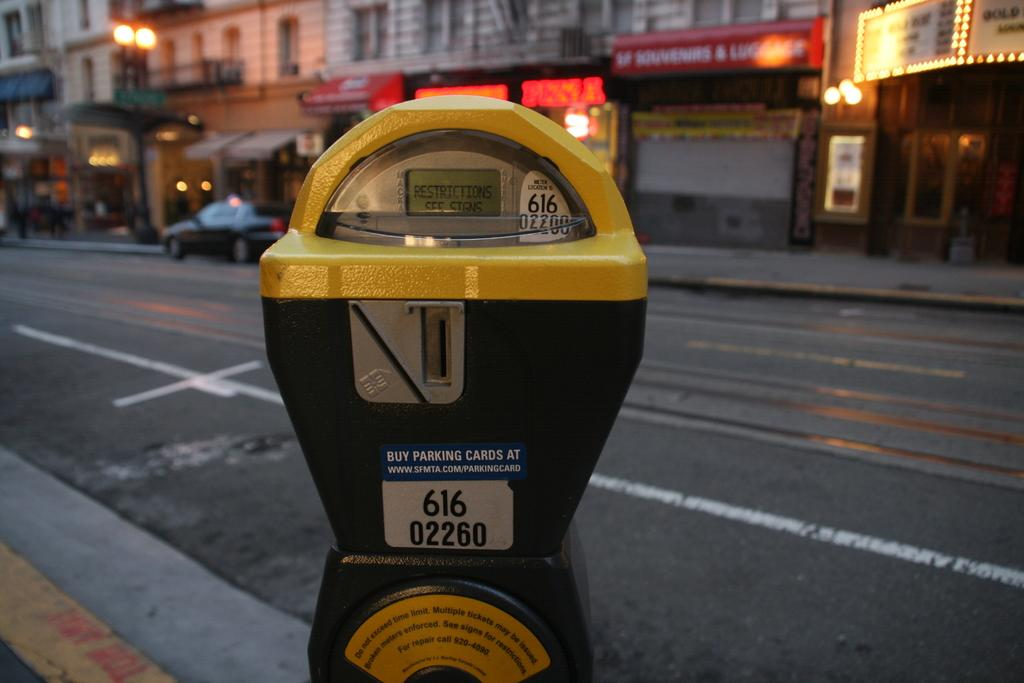<image>
Write a terse but informative summary of the picture. A 616 parking meter on the side of the street. 